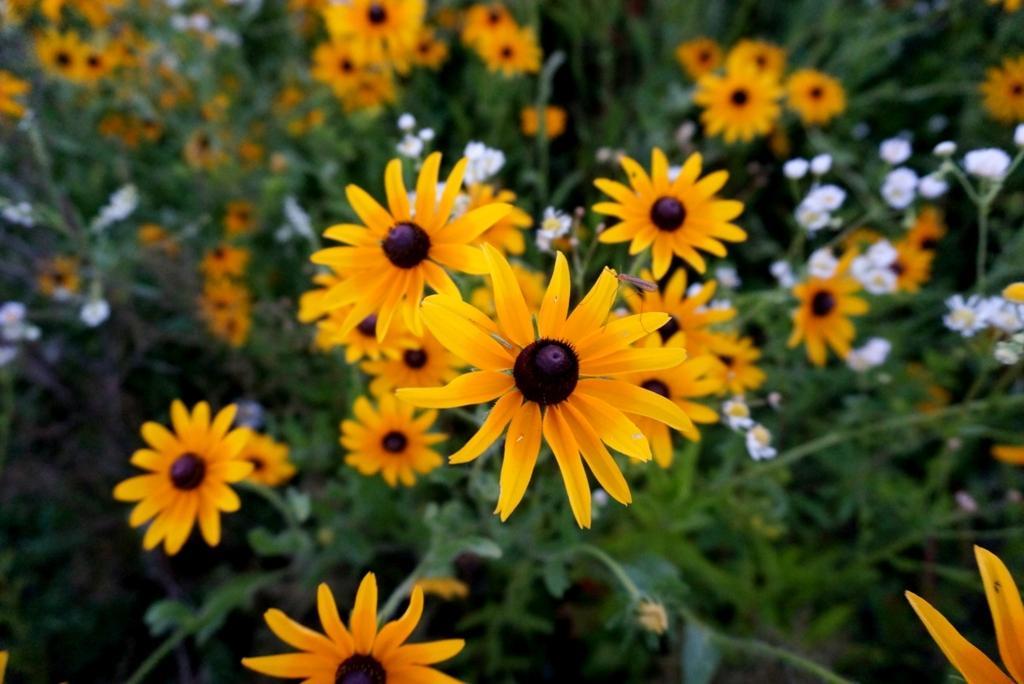In one or two sentences, can you explain what this image depicts? In this image there are flower plants. 